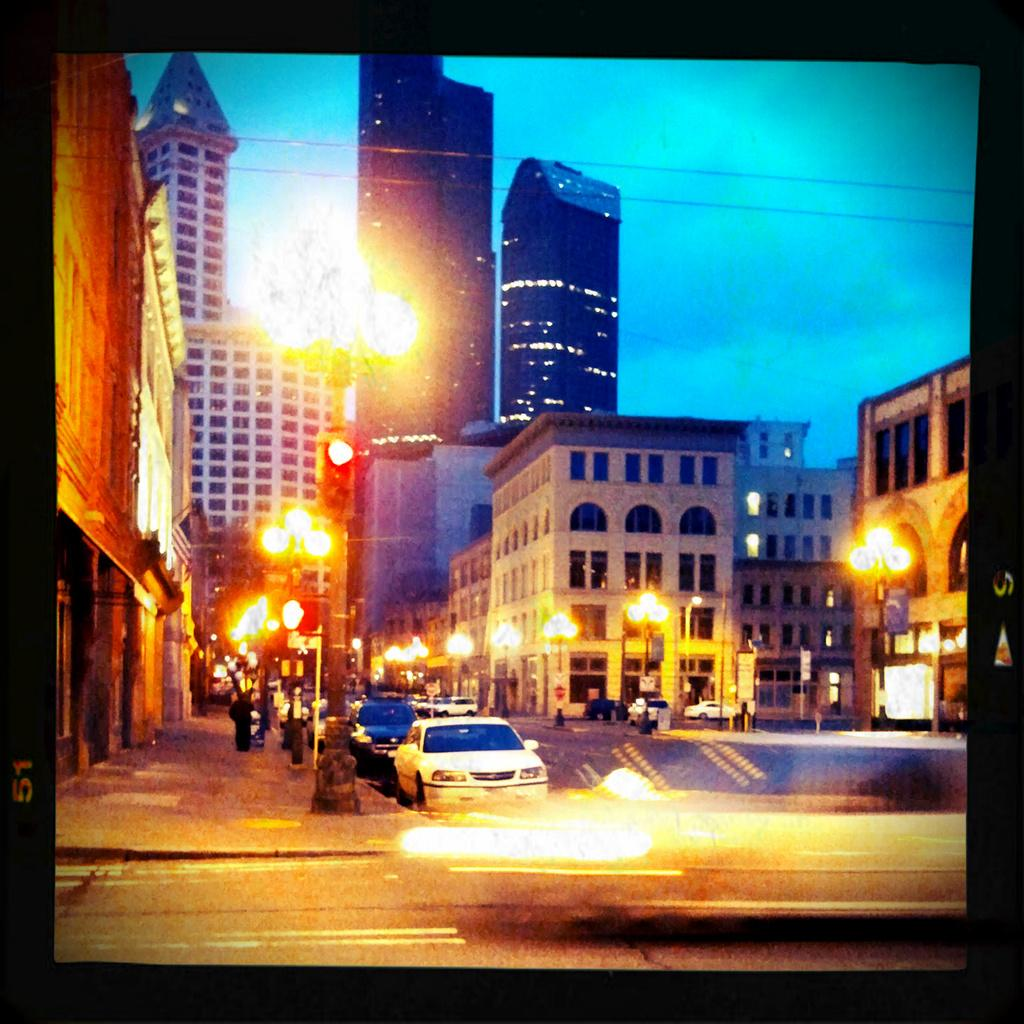What types of objects are in the foreground of the image? There are vehicles and lamp poles in the foreground of the image. What can be seen in the background of the image? There are buildings and the sky visible in the background of the image. How many clocks are hanging on the buildings in the image? There is no information about clocks in the image, so we cannot determine how many are present. 